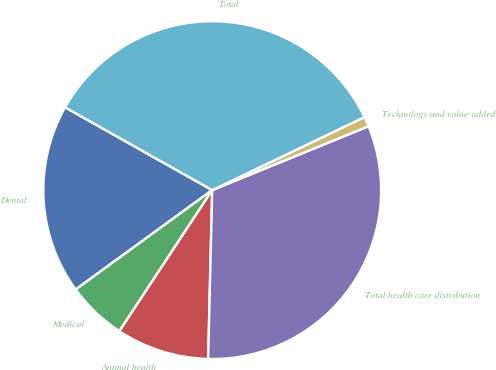Convert chart. <chart><loc_0><loc_0><loc_500><loc_500><pie_chart><fcel>Dental<fcel>Medical<fcel>Animal health<fcel>Total health care distribution<fcel>Technology and value-added<fcel>Total<nl><fcel>18.17%<fcel>5.72%<fcel>8.88%<fcel>31.56%<fcel>0.94%<fcel>34.72%<nl></chart> 